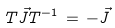<formula> <loc_0><loc_0><loc_500><loc_500>T \vec { J } T ^ { - 1 } \, = \, - \vec { J }</formula> 